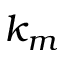Convert formula to latex. <formula><loc_0><loc_0><loc_500><loc_500>k _ { m }</formula> 